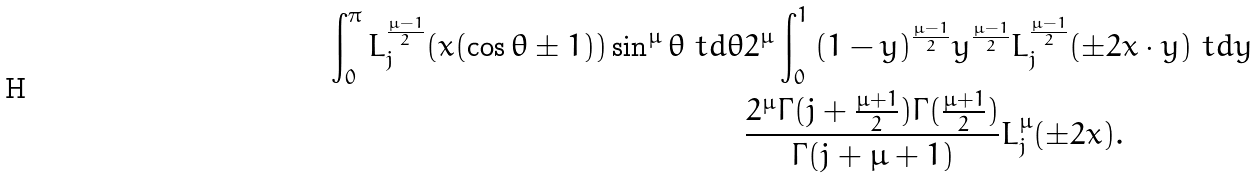<formula> <loc_0><loc_0><loc_500><loc_500>\int _ { 0 } ^ { \pi } { L _ { j } ^ { \frac { \mu - 1 } { 2 } } ( x ( \cos \theta \pm 1 ) ) \sin ^ { \mu } \theta \ t d \theta } & 2 ^ { \mu } \int _ { 0 } ^ { 1 } { ( 1 - y ) ^ { \frac { \mu - 1 } { 2 } } y ^ { \frac { \mu - 1 } { 2 } } L _ { j } ^ { \frac { \mu - 1 } { 2 } } ( \pm 2 x \cdot y ) \ t d y } \\ & \frac { 2 ^ { \mu } \Gamma ( j + \frac { \mu + 1 } { 2 } ) \Gamma ( \frac { \mu + 1 } { 2 } ) } { \Gamma ( j + \mu + 1 ) } L _ { j } ^ { \mu } ( \pm 2 x ) .</formula> 